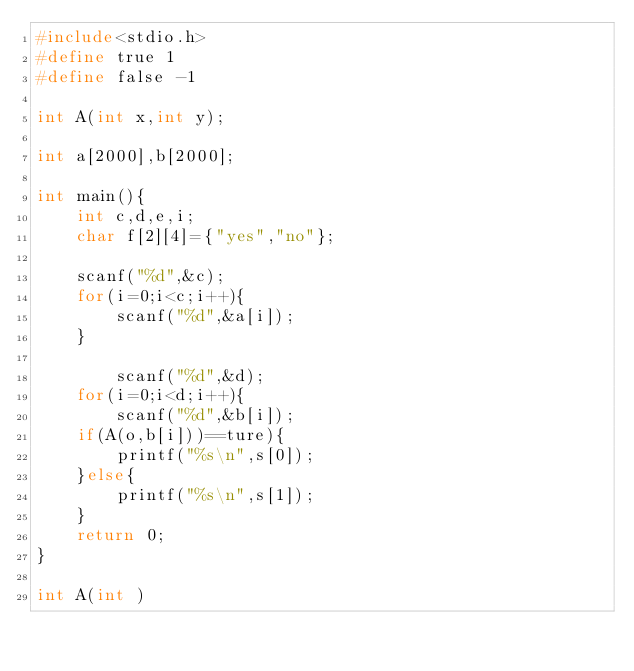Convert code to text. <code><loc_0><loc_0><loc_500><loc_500><_C_>#include<stdio.h>
#define true 1
#define false -1

int A(int x,int y);

int a[2000],b[2000];

int main(){
    int c,d,e,i;
    char f[2][4]={"yes","no"};
    
    scanf("%d",&c);
    for(i=0;i<c;i++){
        scanf("%d",&a[i]);
    }
    
        scanf("%d",&d);
    for(i=0;i<d;i++){
        scanf("%d",&b[i]);
    if(A(o,b[i]))==ture){
        printf("%s\n",s[0]);
    }else{
        printf("%s\n",s[1]);
    }
    return 0;
}

int A(int )
</code> 